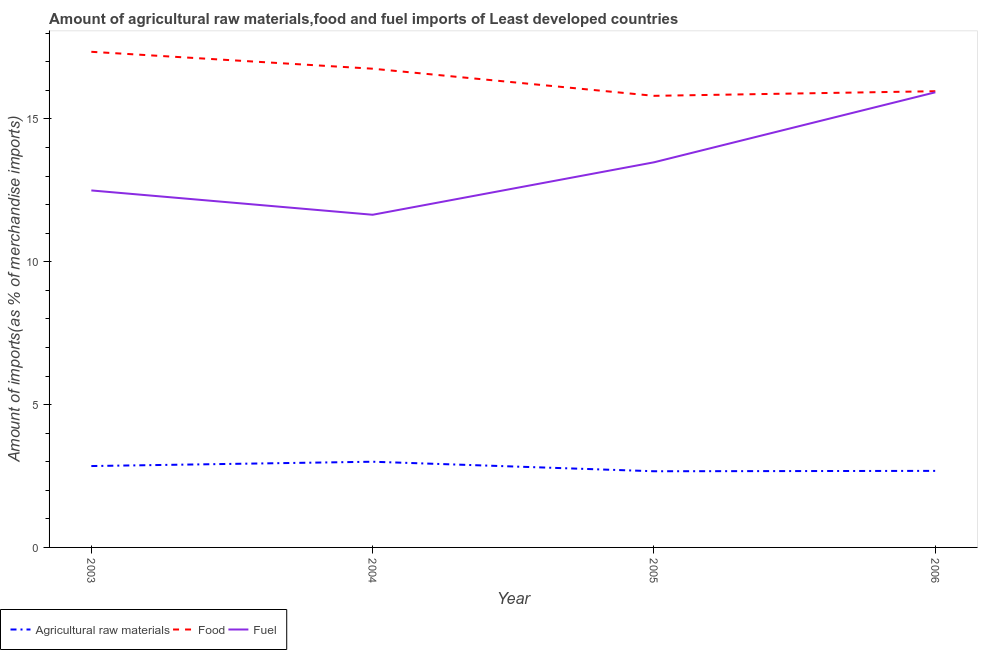How many different coloured lines are there?
Keep it short and to the point. 3. Is the number of lines equal to the number of legend labels?
Provide a succinct answer. Yes. What is the percentage of raw materials imports in 2006?
Give a very brief answer. 2.68. Across all years, what is the maximum percentage of food imports?
Offer a very short reply. 17.35. Across all years, what is the minimum percentage of food imports?
Offer a very short reply. 15.81. What is the total percentage of raw materials imports in the graph?
Ensure brevity in your answer.  11.19. What is the difference between the percentage of food imports in 2003 and that in 2004?
Make the answer very short. 0.59. What is the difference between the percentage of raw materials imports in 2004 and the percentage of food imports in 2003?
Give a very brief answer. -14.35. What is the average percentage of food imports per year?
Your answer should be compact. 16.47. In the year 2003, what is the difference between the percentage of fuel imports and percentage of food imports?
Provide a short and direct response. -4.85. What is the ratio of the percentage of food imports in 2003 to that in 2005?
Your answer should be very brief. 1.1. Is the difference between the percentage of fuel imports in 2005 and 2006 greater than the difference between the percentage of food imports in 2005 and 2006?
Your answer should be very brief. No. What is the difference between the highest and the second highest percentage of fuel imports?
Offer a very short reply. 2.45. What is the difference between the highest and the lowest percentage of raw materials imports?
Your answer should be compact. 0.33. In how many years, is the percentage of fuel imports greater than the average percentage of fuel imports taken over all years?
Provide a succinct answer. 2. Is the sum of the percentage of food imports in 2003 and 2004 greater than the maximum percentage of fuel imports across all years?
Offer a very short reply. Yes. Is it the case that in every year, the sum of the percentage of raw materials imports and percentage of food imports is greater than the percentage of fuel imports?
Your answer should be compact. Yes. Is the percentage of food imports strictly less than the percentage of fuel imports over the years?
Offer a very short reply. No. How many years are there in the graph?
Your answer should be very brief. 4. Are the values on the major ticks of Y-axis written in scientific E-notation?
Offer a very short reply. No. Does the graph contain grids?
Offer a very short reply. No. Where does the legend appear in the graph?
Make the answer very short. Bottom left. How are the legend labels stacked?
Provide a short and direct response. Horizontal. What is the title of the graph?
Make the answer very short. Amount of agricultural raw materials,food and fuel imports of Least developed countries. What is the label or title of the Y-axis?
Offer a very short reply. Amount of imports(as % of merchandise imports). What is the Amount of imports(as % of merchandise imports) of Agricultural raw materials in 2003?
Offer a very short reply. 2.85. What is the Amount of imports(as % of merchandise imports) of Food in 2003?
Your answer should be compact. 17.35. What is the Amount of imports(as % of merchandise imports) of Fuel in 2003?
Offer a terse response. 12.5. What is the Amount of imports(as % of merchandise imports) in Agricultural raw materials in 2004?
Your answer should be compact. 3. What is the Amount of imports(as % of merchandise imports) of Food in 2004?
Provide a short and direct response. 16.76. What is the Amount of imports(as % of merchandise imports) of Fuel in 2004?
Give a very brief answer. 11.64. What is the Amount of imports(as % of merchandise imports) in Agricultural raw materials in 2005?
Keep it short and to the point. 2.67. What is the Amount of imports(as % of merchandise imports) of Food in 2005?
Your answer should be compact. 15.81. What is the Amount of imports(as % of merchandise imports) of Fuel in 2005?
Make the answer very short. 13.48. What is the Amount of imports(as % of merchandise imports) in Agricultural raw materials in 2006?
Keep it short and to the point. 2.68. What is the Amount of imports(as % of merchandise imports) of Food in 2006?
Offer a terse response. 15.97. What is the Amount of imports(as % of merchandise imports) in Fuel in 2006?
Offer a terse response. 15.93. Across all years, what is the maximum Amount of imports(as % of merchandise imports) in Agricultural raw materials?
Your answer should be compact. 3. Across all years, what is the maximum Amount of imports(as % of merchandise imports) in Food?
Give a very brief answer. 17.35. Across all years, what is the maximum Amount of imports(as % of merchandise imports) of Fuel?
Provide a short and direct response. 15.93. Across all years, what is the minimum Amount of imports(as % of merchandise imports) of Agricultural raw materials?
Offer a very short reply. 2.67. Across all years, what is the minimum Amount of imports(as % of merchandise imports) of Food?
Ensure brevity in your answer.  15.81. Across all years, what is the minimum Amount of imports(as % of merchandise imports) of Fuel?
Offer a terse response. 11.64. What is the total Amount of imports(as % of merchandise imports) of Agricultural raw materials in the graph?
Make the answer very short. 11.19. What is the total Amount of imports(as % of merchandise imports) in Food in the graph?
Offer a terse response. 65.88. What is the total Amount of imports(as % of merchandise imports) in Fuel in the graph?
Keep it short and to the point. 53.55. What is the difference between the Amount of imports(as % of merchandise imports) in Agricultural raw materials in 2003 and that in 2004?
Make the answer very short. -0.15. What is the difference between the Amount of imports(as % of merchandise imports) of Food in 2003 and that in 2004?
Provide a short and direct response. 0.59. What is the difference between the Amount of imports(as % of merchandise imports) of Fuel in 2003 and that in 2004?
Provide a succinct answer. 0.85. What is the difference between the Amount of imports(as % of merchandise imports) in Agricultural raw materials in 2003 and that in 2005?
Your answer should be very brief. 0.18. What is the difference between the Amount of imports(as % of merchandise imports) in Food in 2003 and that in 2005?
Your answer should be compact. 1.54. What is the difference between the Amount of imports(as % of merchandise imports) of Fuel in 2003 and that in 2005?
Provide a short and direct response. -0.98. What is the difference between the Amount of imports(as % of merchandise imports) in Agricultural raw materials in 2003 and that in 2006?
Ensure brevity in your answer.  0.17. What is the difference between the Amount of imports(as % of merchandise imports) of Food in 2003 and that in 2006?
Ensure brevity in your answer.  1.38. What is the difference between the Amount of imports(as % of merchandise imports) in Fuel in 2003 and that in 2006?
Offer a very short reply. -3.44. What is the difference between the Amount of imports(as % of merchandise imports) in Agricultural raw materials in 2004 and that in 2005?
Ensure brevity in your answer.  0.33. What is the difference between the Amount of imports(as % of merchandise imports) of Food in 2004 and that in 2005?
Keep it short and to the point. 0.95. What is the difference between the Amount of imports(as % of merchandise imports) in Fuel in 2004 and that in 2005?
Your answer should be compact. -1.84. What is the difference between the Amount of imports(as % of merchandise imports) of Agricultural raw materials in 2004 and that in 2006?
Offer a terse response. 0.32. What is the difference between the Amount of imports(as % of merchandise imports) in Food in 2004 and that in 2006?
Provide a short and direct response. 0.79. What is the difference between the Amount of imports(as % of merchandise imports) in Fuel in 2004 and that in 2006?
Ensure brevity in your answer.  -4.29. What is the difference between the Amount of imports(as % of merchandise imports) in Agricultural raw materials in 2005 and that in 2006?
Give a very brief answer. -0.01. What is the difference between the Amount of imports(as % of merchandise imports) in Food in 2005 and that in 2006?
Provide a short and direct response. -0.16. What is the difference between the Amount of imports(as % of merchandise imports) in Fuel in 2005 and that in 2006?
Your response must be concise. -2.45. What is the difference between the Amount of imports(as % of merchandise imports) of Agricultural raw materials in 2003 and the Amount of imports(as % of merchandise imports) of Food in 2004?
Offer a very short reply. -13.91. What is the difference between the Amount of imports(as % of merchandise imports) in Agricultural raw materials in 2003 and the Amount of imports(as % of merchandise imports) in Fuel in 2004?
Make the answer very short. -8.8. What is the difference between the Amount of imports(as % of merchandise imports) in Food in 2003 and the Amount of imports(as % of merchandise imports) in Fuel in 2004?
Provide a succinct answer. 5.7. What is the difference between the Amount of imports(as % of merchandise imports) of Agricultural raw materials in 2003 and the Amount of imports(as % of merchandise imports) of Food in 2005?
Provide a succinct answer. -12.96. What is the difference between the Amount of imports(as % of merchandise imports) of Agricultural raw materials in 2003 and the Amount of imports(as % of merchandise imports) of Fuel in 2005?
Give a very brief answer. -10.63. What is the difference between the Amount of imports(as % of merchandise imports) in Food in 2003 and the Amount of imports(as % of merchandise imports) in Fuel in 2005?
Provide a short and direct response. 3.87. What is the difference between the Amount of imports(as % of merchandise imports) of Agricultural raw materials in 2003 and the Amount of imports(as % of merchandise imports) of Food in 2006?
Keep it short and to the point. -13.12. What is the difference between the Amount of imports(as % of merchandise imports) in Agricultural raw materials in 2003 and the Amount of imports(as % of merchandise imports) in Fuel in 2006?
Give a very brief answer. -13.08. What is the difference between the Amount of imports(as % of merchandise imports) in Food in 2003 and the Amount of imports(as % of merchandise imports) in Fuel in 2006?
Your answer should be compact. 1.42. What is the difference between the Amount of imports(as % of merchandise imports) in Agricultural raw materials in 2004 and the Amount of imports(as % of merchandise imports) in Food in 2005?
Keep it short and to the point. -12.81. What is the difference between the Amount of imports(as % of merchandise imports) of Agricultural raw materials in 2004 and the Amount of imports(as % of merchandise imports) of Fuel in 2005?
Provide a short and direct response. -10.48. What is the difference between the Amount of imports(as % of merchandise imports) of Food in 2004 and the Amount of imports(as % of merchandise imports) of Fuel in 2005?
Provide a succinct answer. 3.28. What is the difference between the Amount of imports(as % of merchandise imports) in Agricultural raw materials in 2004 and the Amount of imports(as % of merchandise imports) in Food in 2006?
Offer a terse response. -12.97. What is the difference between the Amount of imports(as % of merchandise imports) in Agricultural raw materials in 2004 and the Amount of imports(as % of merchandise imports) in Fuel in 2006?
Keep it short and to the point. -12.93. What is the difference between the Amount of imports(as % of merchandise imports) in Food in 2004 and the Amount of imports(as % of merchandise imports) in Fuel in 2006?
Your answer should be compact. 0.83. What is the difference between the Amount of imports(as % of merchandise imports) of Agricultural raw materials in 2005 and the Amount of imports(as % of merchandise imports) of Food in 2006?
Your answer should be compact. -13.3. What is the difference between the Amount of imports(as % of merchandise imports) in Agricultural raw materials in 2005 and the Amount of imports(as % of merchandise imports) in Fuel in 2006?
Offer a very short reply. -13.26. What is the difference between the Amount of imports(as % of merchandise imports) in Food in 2005 and the Amount of imports(as % of merchandise imports) in Fuel in 2006?
Your response must be concise. -0.12. What is the average Amount of imports(as % of merchandise imports) of Agricultural raw materials per year?
Offer a very short reply. 2.8. What is the average Amount of imports(as % of merchandise imports) in Food per year?
Your answer should be very brief. 16.47. What is the average Amount of imports(as % of merchandise imports) of Fuel per year?
Offer a very short reply. 13.39. In the year 2003, what is the difference between the Amount of imports(as % of merchandise imports) in Agricultural raw materials and Amount of imports(as % of merchandise imports) in Food?
Your response must be concise. -14.5. In the year 2003, what is the difference between the Amount of imports(as % of merchandise imports) of Agricultural raw materials and Amount of imports(as % of merchandise imports) of Fuel?
Provide a succinct answer. -9.65. In the year 2003, what is the difference between the Amount of imports(as % of merchandise imports) of Food and Amount of imports(as % of merchandise imports) of Fuel?
Your answer should be compact. 4.85. In the year 2004, what is the difference between the Amount of imports(as % of merchandise imports) of Agricultural raw materials and Amount of imports(as % of merchandise imports) of Food?
Provide a succinct answer. -13.76. In the year 2004, what is the difference between the Amount of imports(as % of merchandise imports) in Agricultural raw materials and Amount of imports(as % of merchandise imports) in Fuel?
Provide a short and direct response. -8.64. In the year 2004, what is the difference between the Amount of imports(as % of merchandise imports) of Food and Amount of imports(as % of merchandise imports) of Fuel?
Provide a succinct answer. 5.11. In the year 2005, what is the difference between the Amount of imports(as % of merchandise imports) in Agricultural raw materials and Amount of imports(as % of merchandise imports) in Food?
Provide a succinct answer. -13.14. In the year 2005, what is the difference between the Amount of imports(as % of merchandise imports) of Agricultural raw materials and Amount of imports(as % of merchandise imports) of Fuel?
Your answer should be very brief. -10.81. In the year 2005, what is the difference between the Amount of imports(as % of merchandise imports) in Food and Amount of imports(as % of merchandise imports) in Fuel?
Give a very brief answer. 2.33. In the year 2006, what is the difference between the Amount of imports(as % of merchandise imports) of Agricultural raw materials and Amount of imports(as % of merchandise imports) of Food?
Keep it short and to the point. -13.29. In the year 2006, what is the difference between the Amount of imports(as % of merchandise imports) in Agricultural raw materials and Amount of imports(as % of merchandise imports) in Fuel?
Give a very brief answer. -13.25. In the year 2006, what is the difference between the Amount of imports(as % of merchandise imports) in Food and Amount of imports(as % of merchandise imports) in Fuel?
Your answer should be compact. 0.04. What is the ratio of the Amount of imports(as % of merchandise imports) of Agricultural raw materials in 2003 to that in 2004?
Provide a short and direct response. 0.95. What is the ratio of the Amount of imports(as % of merchandise imports) of Food in 2003 to that in 2004?
Ensure brevity in your answer.  1.04. What is the ratio of the Amount of imports(as % of merchandise imports) of Fuel in 2003 to that in 2004?
Your response must be concise. 1.07. What is the ratio of the Amount of imports(as % of merchandise imports) in Agricultural raw materials in 2003 to that in 2005?
Provide a short and direct response. 1.07. What is the ratio of the Amount of imports(as % of merchandise imports) in Food in 2003 to that in 2005?
Your response must be concise. 1.1. What is the ratio of the Amount of imports(as % of merchandise imports) in Fuel in 2003 to that in 2005?
Your response must be concise. 0.93. What is the ratio of the Amount of imports(as % of merchandise imports) in Agricultural raw materials in 2003 to that in 2006?
Ensure brevity in your answer.  1.06. What is the ratio of the Amount of imports(as % of merchandise imports) of Food in 2003 to that in 2006?
Offer a terse response. 1.09. What is the ratio of the Amount of imports(as % of merchandise imports) in Fuel in 2003 to that in 2006?
Offer a terse response. 0.78. What is the ratio of the Amount of imports(as % of merchandise imports) of Agricultural raw materials in 2004 to that in 2005?
Provide a succinct answer. 1.13. What is the ratio of the Amount of imports(as % of merchandise imports) in Food in 2004 to that in 2005?
Give a very brief answer. 1.06. What is the ratio of the Amount of imports(as % of merchandise imports) in Fuel in 2004 to that in 2005?
Offer a very short reply. 0.86. What is the ratio of the Amount of imports(as % of merchandise imports) of Agricultural raw materials in 2004 to that in 2006?
Keep it short and to the point. 1.12. What is the ratio of the Amount of imports(as % of merchandise imports) of Food in 2004 to that in 2006?
Your response must be concise. 1.05. What is the ratio of the Amount of imports(as % of merchandise imports) of Fuel in 2004 to that in 2006?
Ensure brevity in your answer.  0.73. What is the ratio of the Amount of imports(as % of merchandise imports) in Food in 2005 to that in 2006?
Provide a succinct answer. 0.99. What is the ratio of the Amount of imports(as % of merchandise imports) of Fuel in 2005 to that in 2006?
Ensure brevity in your answer.  0.85. What is the difference between the highest and the second highest Amount of imports(as % of merchandise imports) of Agricultural raw materials?
Your response must be concise. 0.15. What is the difference between the highest and the second highest Amount of imports(as % of merchandise imports) of Food?
Provide a succinct answer. 0.59. What is the difference between the highest and the second highest Amount of imports(as % of merchandise imports) of Fuel?
Provide a succinct answer. 2.45. What is the difference between the highest and the lowest Amount of imports(as % of merchandise imports) in Agricultural raw materials?
Give a very brief answer. 0.33. What is the difference between the highest and the lowest Amount of imports(as % of merchandise imports) in Food?
Your answer should be very brief. 1.54. What is the difference between the highest and the lowest Amount of imports(as % of merchandise imports) of Fuel?
Your answer should be compact. 4.29. 